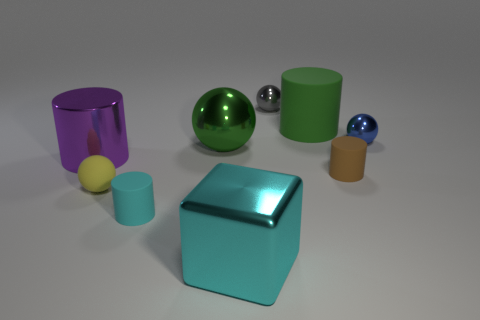Add 1 small blue shiny spheres. How many objects exist? 10 Subtract all tiny cyan cylinders. How many cylinders are left? 3 Subtract all spheres. How many objects are left? 5 Subtract 1 blocks. How many blocks are left? 0 Add 8 brown metallic blocks. How many brown metallic blocks exist? 8 Subtract all purple cylinders. How many cylinders are left? 3 Subtract 1 blue spheres. How many objects are left? 8 Subtract all red balls. Subtract all brown cubes. How many balls are left? 4 Subtract all tiny red cubes. Subtract all brown things. How many objects are left? 8 Add 7 tiny metallic objects. How many tiny metallic objects are left? 9 